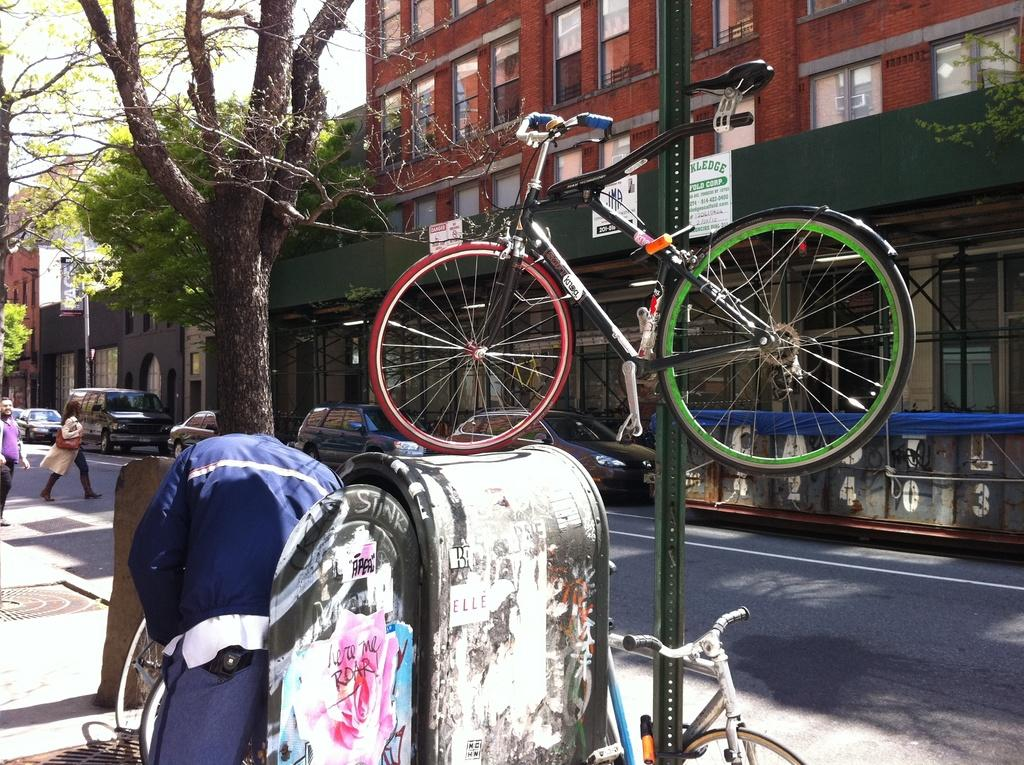What type of transportation can be seen in the image? There are bicycles in the image. Who is present in the image? There is a group of people in the image. What else can be seen on the road in the image? There are vehicles on the road in the image. What objects are present in the image that are not related to transportation? There are boards in the image. What type of natural elements can be seen in the image? There are trees in the image. What type of man-made structures can be seen in the image? There are buildings in the image. What is visible in the background of the image? The sky is visible in the background of the image. What type of battle is taking place in the image? There is no battle present in the image; it features bicycles, a group of people, vehicles, boards, trees, buildings, and the sky. Can you describe the man who is leading the battle in the image? There is no man leading a battle in the image, as there is no battle depicted. 